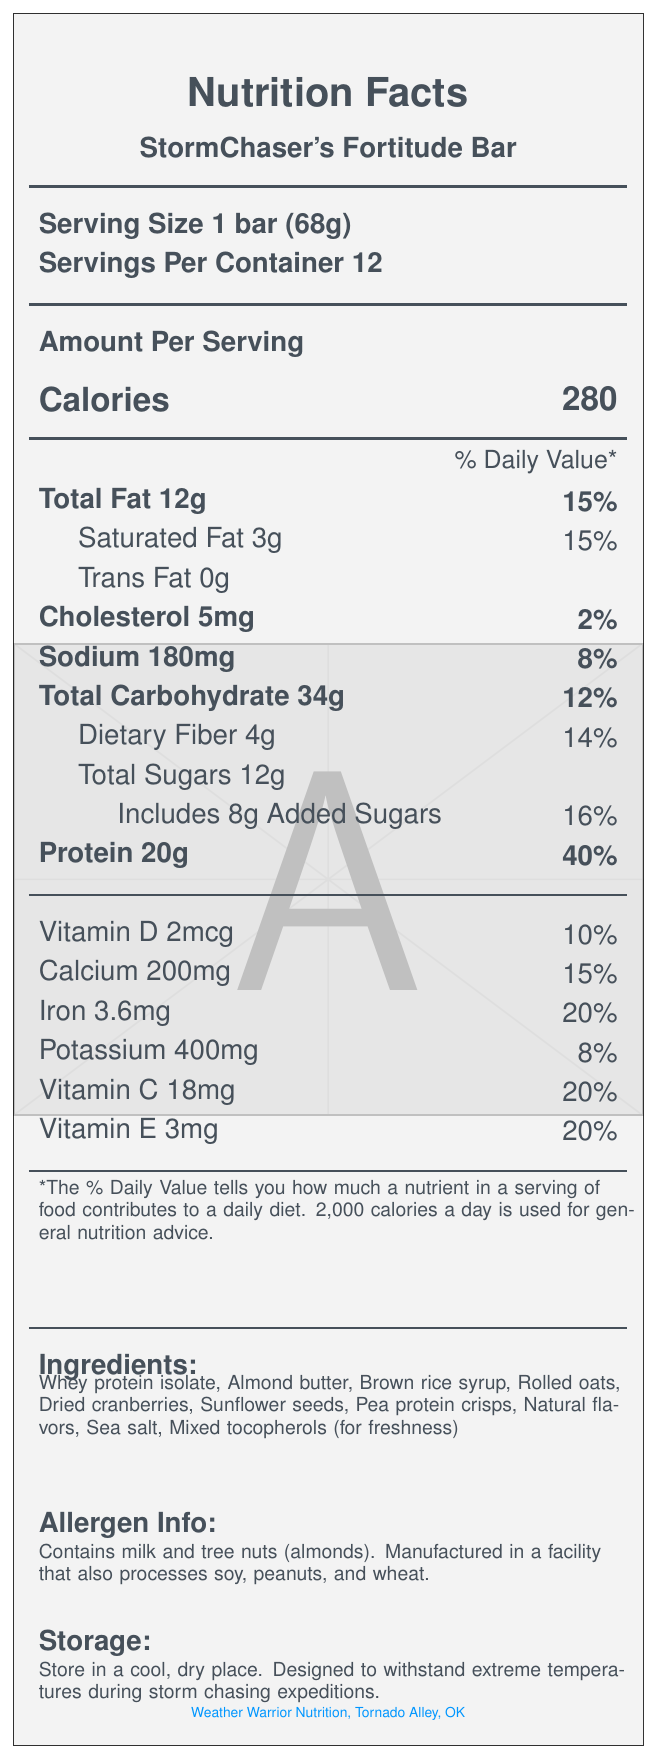What is the serving size for StormChaser's Fortitude Bar? The serving size is listed as "1 bar (68g)" in the Nutrition Facts section.
Answer: 1 bar (68g) How many servings are there per container? The document specifies "Servings Per Container 12".
Answer: 12 What is the amount of protein per serving? Under the Protein section, it states "Protein 20g".
Answer: 20g What percentage of the daily value of saturated fat does one bar provide? The document shows "Saturated Fat 3g, 15%" under the Total Fat section.
Answer: 15% What are the first three ingredients listed for StormChaser's Fortitude Bar? The Ingredients section lists them as "Whey protein isolate, Almond butter, Brown rice syrup".
Answer: Whey protein isolate, Almond butter, Brown rice syrup How many calories are in one serving of the protein bar? A. 250 B. 270 C. 280 D. 300 The document clearly states "Calories 280".
Answer: C Which of the following certifications does the bar have? A. Vegan B. Non-GMO Project Verified C. Organic D. Paleo The document lists "Non-GMO Project Verified" under certifications.
Answer: B Is the StormChaser's Fortitude Bar gluten-free? The Certifications section states the bar is "Certified Gluten-Free".
Answer: Yes Does the bar contain any allergens? The Allergen Info section indicates that it contains milk and tree nuts (almonds) and is manufactured in a facility that also processes soy, peanuts, and wheat.
Answer: Yes Summarize the special features of the StormChaser's Fortitude Bar. The Special Features section lists these attributes directly.
Answer: High in protein, weather-resistant packaging, formulated to withstand extreme temperatures, enhanced with electrolytes, long shelf life What is the total amount of sugar in one bar, including added sugars? The document lists "Total Sugars 12g" and specifies "Includes 8g Added Sugars".
Answer: 12g of total sugars, with 8g being added sugars What percentage of the daily value for iron does one bar provide? Under the vitamins and minerals section, it states "Iron 3.6mg, 20%".
Answer: 20% What is the main purpose of mixed tocopherols in the ingredients? The ingredients list includes "Mixed tocopherols (for freshness)".
Answer: For freshness What percentage of the daily value for sodium does one serving contain? The sodium content is listed as "Sodium 180mg, 8%".
Answer: 8% Can the document tell if this protein bar is safe for someone with a peanut allergy? The ingredient list does not include peanuts, but the allergen info notes that it is manufactured in a facility that processes peanuts.
Answer: Not enough information What are the storage instructions for the StormChaser's Fortitude Bar? The Storage section provides these specific instructions.
Answer: Store in a cool, dry place. Designed to withstand extreme temperatures during storm chasing expeditions. 